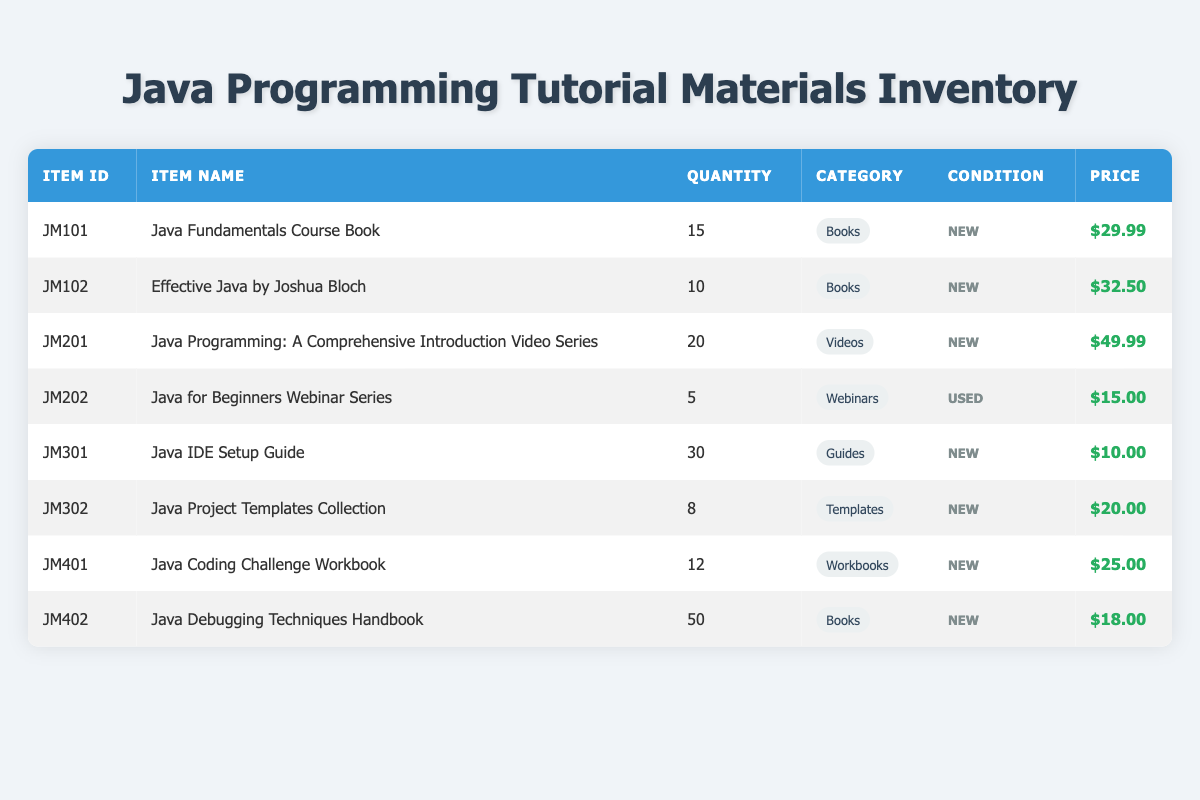What is the item ID for the "Java Fundamentals Course Book"? The item ID is clearly listed in the table under the "Item ID" column next to the "Java Fundamentals Course Book". It is JM101.
Answer: JM101 How many Java project template collections are available? The quantity of "Java Project Templates Collection" is specified in the "Quantity" column of the table, which shows there are 8 available.
Answer: 8 What is the total value of all items in the "Books" category? To find the total value, add the prices of all items in the "Books" category: (29.99 + 32.50 + 18.00) and multiply by their quantities: (15 * 29.99) + (10 * 32.50) + (50 * 18.00) = 449.85 + 325.00 + 900.00 = 1674.85.
Answer: 1674.85 Is there any item in used condition? By reviewing the "Condition" column, we can see that "Java for Beginners Webinar Series" is the only item listed as used. Therefore, the answer is yes.
Answer: Yes What is the average price of the items listed in the "Webinars" category? The "Webinars" category has only one item, which is priced at 15.00. Since there's only one value, the average price is the same: 15.00 / 1 = 15.00.
Answer: 15.00 Which item has the highest quantity available in the inventory? By examining the "Quantity" column, the "Java Debugging Techniques Handbook" has the highest quantity listed at 50, compared to other items.
Answer: Java Debugging Techniques Handbook How many types of Java programming materials are available, based on the categories? The categories listed include Books, Videos, Webinars, Guides, and Templates, making a total of 5 unique categories present in the inventory.
Answer: 5 What is the total number of Java IDE Setup Guides and Coding Challenge Workbooks combined? The quantity of Java IDE Setup Guides is 30, and the quantity of Coding Challenge Workbooks is 12. Adding these together gives 30 + 12 = 42.
Answer: 42 Is the “Effective Java by Joshua Bloch” priced lower than $35? The price for “Effective Java by Joshua Bloch” is listed as 32.50. Since this is less than 35, the answer is yes.
Answer: Yes 